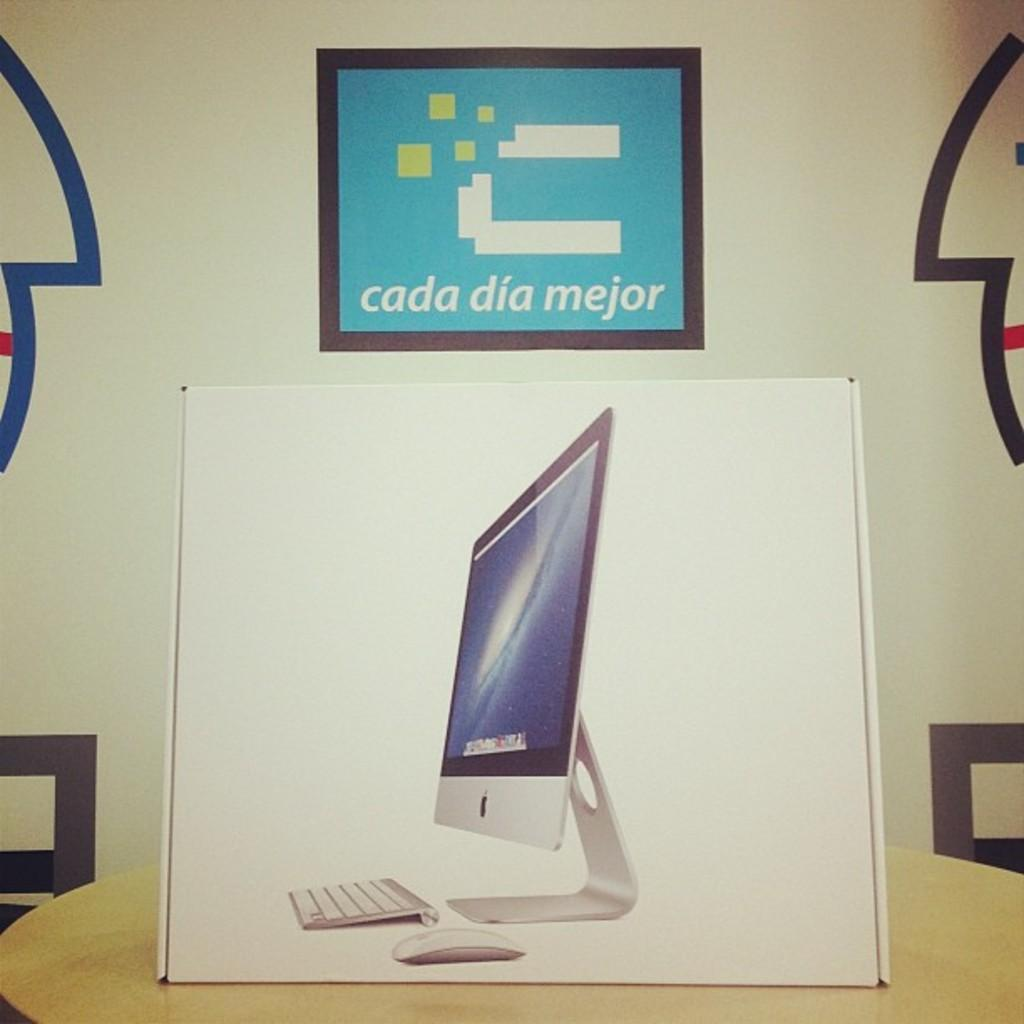<image>
Describe the image concisely. The sign on the wall says cada dia mejor 